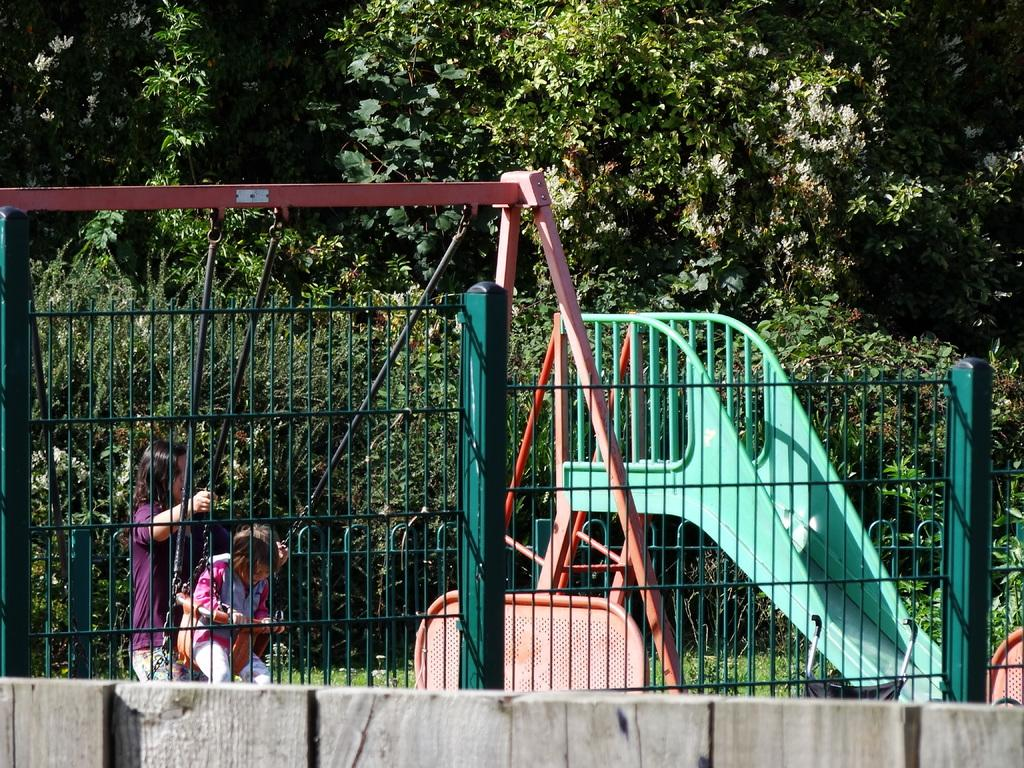What type of structure can be seen in the image? There is a fencing in the image. What are the children doing in the image? Two children are playing on a swing. Are there any other playground equipment visible in the image? Yes, there is a slider in the image. What can be seen in the background of the image? There are plants, grass, and trees in the background of the image. Where is the chair located in the image? There is no chair present in the image. Is there a bomb visible in the image? No, there is no bomb visible in the image. 